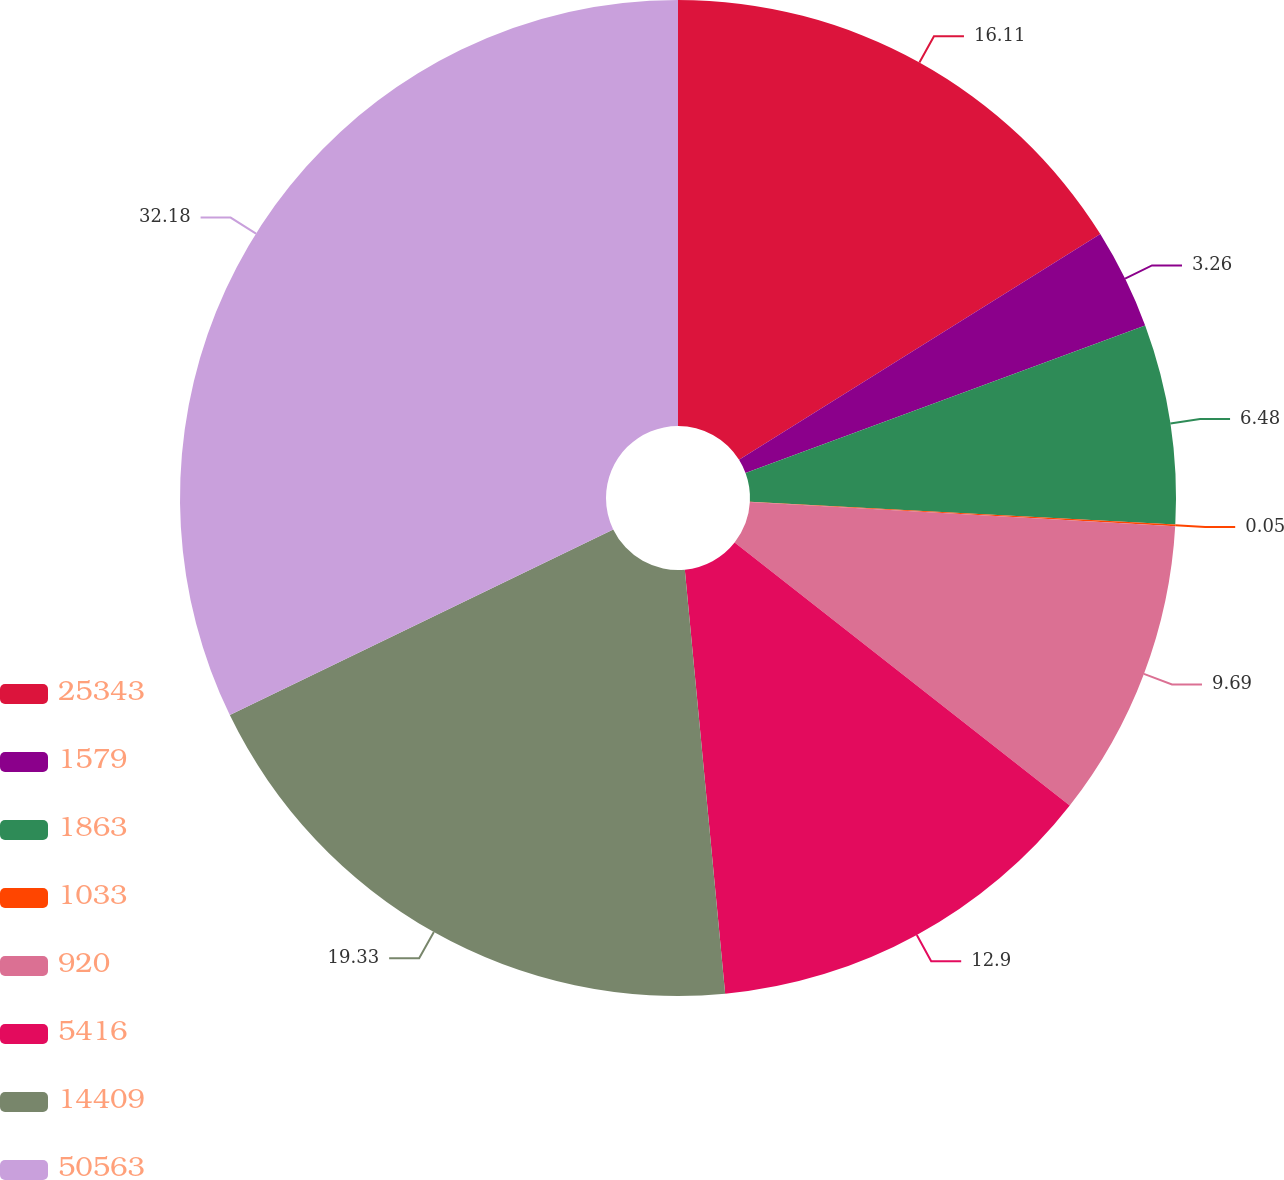<chart> <loc_0><loc_0><loc_500><loc_500><pie_chart><fcel>25343<fcel>1579<fcel>1863<fcel>1033<fcel>920<fcel>5416<fcel>14409<fcel>50563<nl><fcel>16.11%<fcel>3.26%<fcel>6.48%<fcel>0.05%<fcel>9.69%<fcel>12.9%<fcel>19.33%<fcel>32.18%<nl></chart> 